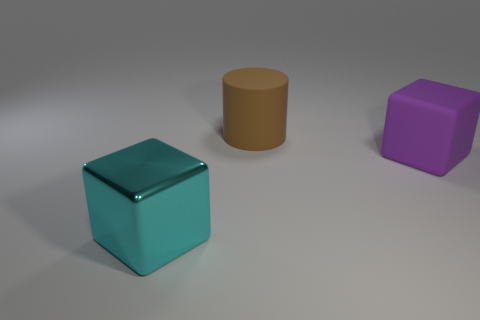Is the big cyan cube made of the same material as the purple cube?
Your response must be concise. No. Are there any large cyan shiny blocks that are to the right of the large block on the right side of the large cyan metal thing?
Keep it short and to the point. No. Is there a big purple thing that has the same shape as the large cyan thing?
Ensure brevity in your answer.  Yes. Does the cylinder have the same color as the rubber block?
Offer a very short reply. No. There is a large block that is on the left side of the large matte object that is behind the rubber cube; what is it made of?
Give a very brief answer. Metal. The matte cube is what size?
Keep it short and to the point. Large. There is a purple cube that is made of the same material as the brown cylinder; what is its size?
Provide a succinct answer. Large. There is a rubber object on the left side of the purple thing; is it the same size as the purple thing?
Make the answer very short. Yes. What shape is the big matte object that is on the right side of the large matte thing on the left side of the big rubber object in front of the big brown rubber thing?
Your answer should be compact. Cube. What number of things are either cyan blocks or big objects that are on the left side of the big purple block?
Offer a very short reply. 2. 